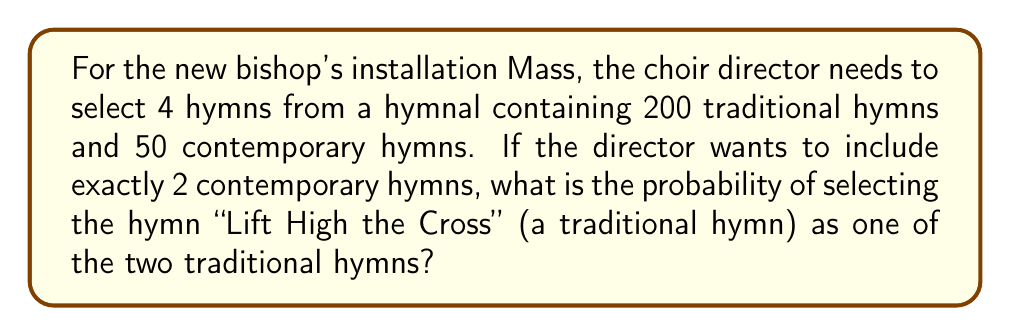Show me your answer to this math problem. Let's approach this step-by-step:

1) First, we need to calculate the number of ways to select the hymns:
   - 2 contemporary hymns from 50: $\binom{50}{2}$
   - 2 traditional hymns from 200: $\binom{200}{2}$

2) The total number of ways to select the hymns is:
   $$ \binom{50}{2} \cdot \binom{200}{2} $$

3) Now, we need to calculate the number of ways to select the hymns that include "Lift High the Cross":
   - 2 contemporary hymns from 50: $\binom{50}{2}$
   - 1 traditional hymn (Lift High the Cross) is already selected, so we need to choose 1 more from the remaining 199: $\binom{199}{1}$

4) The number of favorable outcomes is:
   $$ \binom{50}{2} \cdot \binom{199}{1} $$

5) The probability is the number of favorable outcomes divided by the total number of outcomes:

   $$ P(\text{Lift High the Cross}) = \frac{\binom{50}{2} \cdot \binom{199}{1}}{\binom{50}{2} \cdot \binom{200}{2}} = \frac{\binom{199}{1}}{\binom{200}{2}} $$

6) Simplify:
   $$ \frac{199}{200 \cdot 199/2} = \frac{199}{19900} = \frac{1}{100} $$
Answer: $\frac{1}{100}$ 